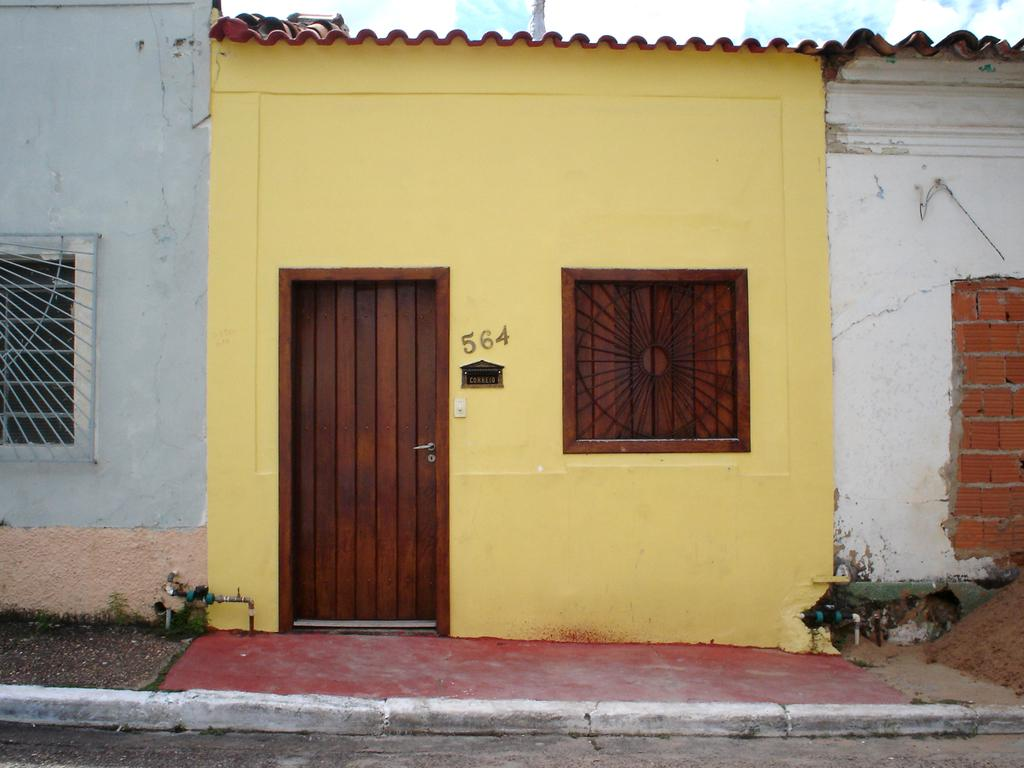What type of structure is visible in the image? There is a house in the image. What are the main features of the house? The house has walls, windows, and a door. Is there any signage or identification for the house? Yes, there is a name board in the image. Are there any other objects or features in the image? Yes, there is a pipe, a handle, a walkway, and a road in the image. Can you tell me how many times the cracker was smashed in the image? There is no cracker present in the image, so it cannot be determined how many times it was smashed. What memories does the house evoke for the person looking at the image? The image does not provide any information about the person looking at it or their memories, so it cannot be determined what memories the house evokes. 